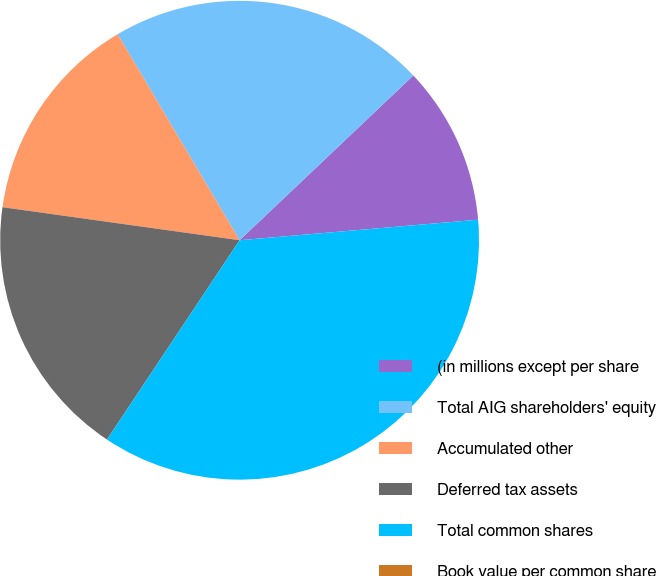Convert chart to OTSL. <chart><loc_0><loc_0><loc_500><loc_500><pie_chart><fcel>(in millions except per share<fcel>Total AIG shareholders' equity<fcel>Accumulated other<fcel>Deferred tax assets<fcel>Total common shares<fcel>Book value per common share<nl><fcel>10.71%<fcel>21.43%<fcel>14.29%<fcel>17.86%<fcel>35.71%<fcel>0.0%<nl></chart> 